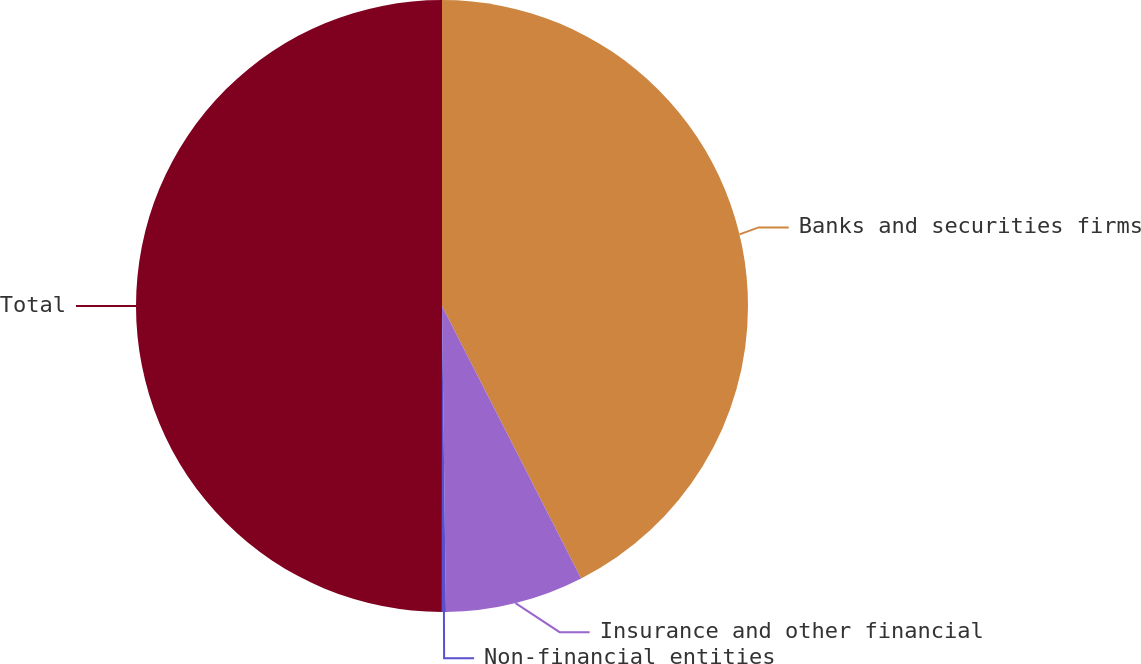Convert chart. <chart><loc_0><loc_0><loc_500><loc_500><pie_chart><fcel>Banks and securities firms<fcel>Insurance and other financial<fcel>Non-financial entities<fcel>Total<nl><fcel>42.49%<fcel>7.31%<fcel>0.21%<fcel>50.0%<nl></chart> 